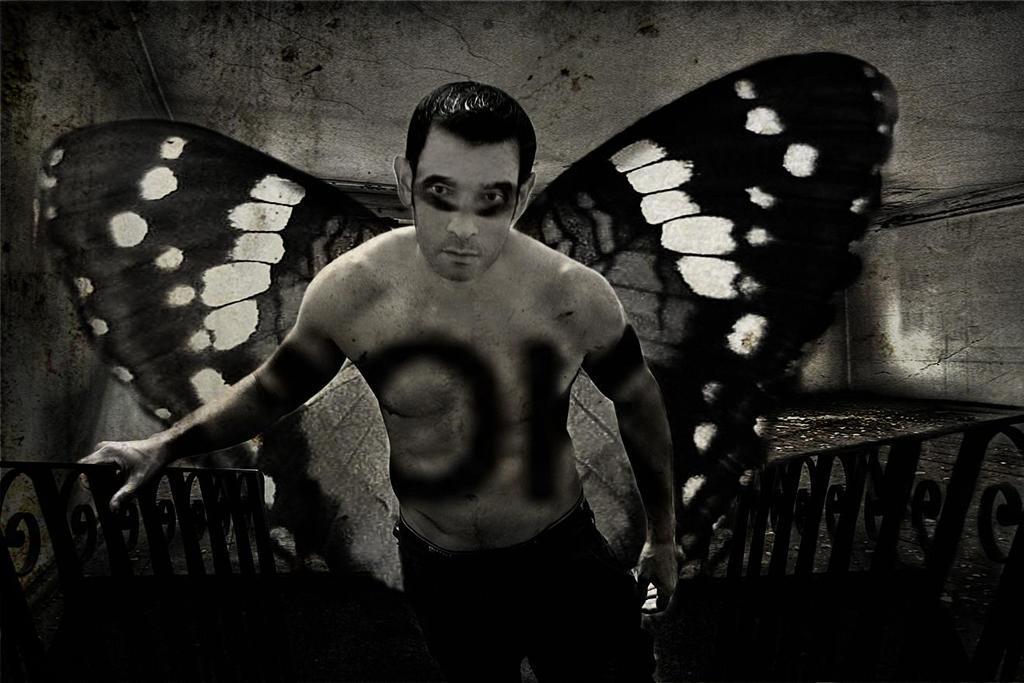In one or two sentences, can you explain what this image depicts? Here in this picture we can see a man standing on a staircase with railing present on either side and we can see he is wearing butterfly wings behind him and we can see some makeup is done on to his body and face over there. 